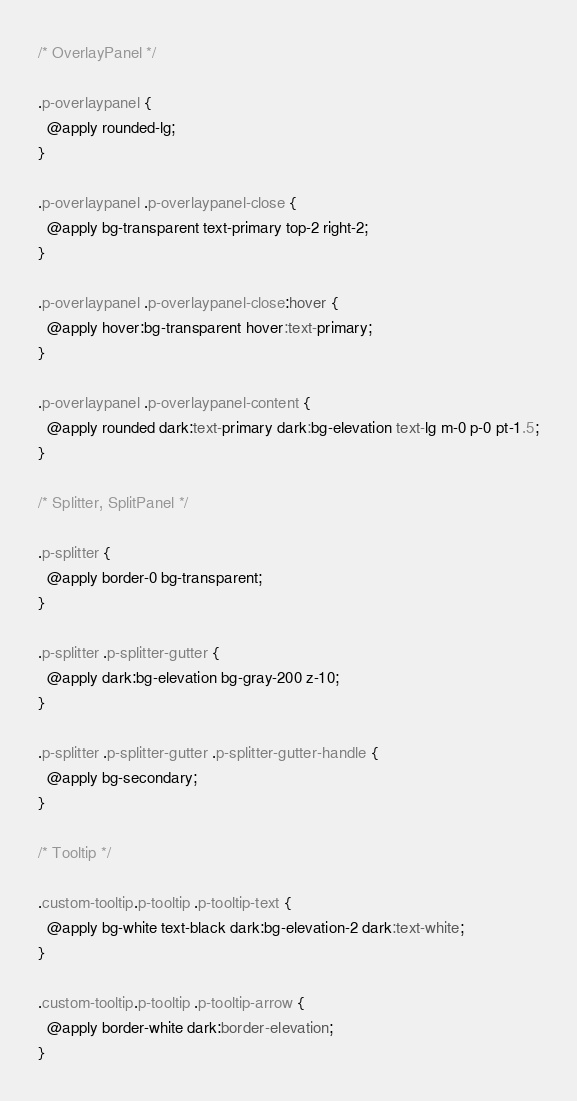Convert code to text. <code><loc_0><loc_0><loc_500><loc_500><_CSS_>/* OverlayPanel */

.p-overlaypanel {
  @apply rounded-lg;
}

.p-overlaypanel .p-overlaypanel-close {
  @apply bg-transparent text-primary top-2 right-2;
}

.p-overlaypanel .p-overlaypanel-close:hover {
  @apply hover:bg-transparent hover:text-primary;
}

.p-overlaypanel .p-overlaypanel-content {
  @apply rounded dark:text-primary dark:bg-elevation text-lg m-0 p-0 pt-1.5;
}

/* Splitter, SplitPanel */

.p-splitter {
  @apply border-0 bg-transparent;
}

.p-splitter .p-splitter-gutter {
  @apply dark:bg-elevation bg-gray-200 z-10;
}

.p-splitter .p-splitter-gutter .p-splitter-gutter-handle {
  @apply bg-secondary;
}

/* Tooltip */

.custom-tooltip.p-tooltip .p-tooltip-text {
  @apply bg-white text-black dark:bg-elevation-2 dark:text-white;
}

.custom-tooltip.p-tooltip .p-tooltip-arrow {
  @apply border-white dark:border-elevation;
}
</code> 